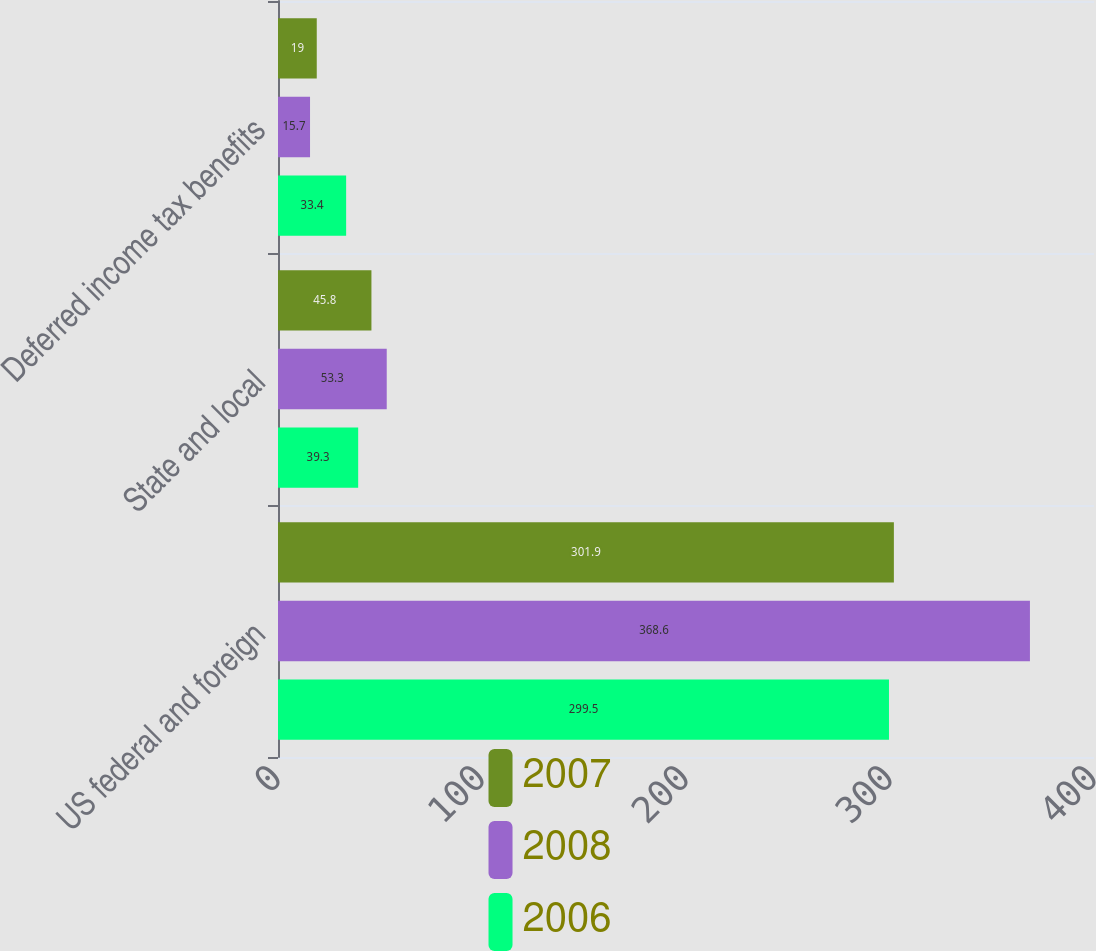<chart> <loc_0><loc_0><loc_500><loc_500><stacked_bar_chart><ecel><fcel>US federal and foreign<fcel>State and local<fcel>Deferred income tax benefits<nl><fcel>2007<fcel>301.9<fcel>45.8<fcel>19<nl><fcel>2008<fcel>368.6<fcel>53.3<fcel>15.7<nl><fcel>2006<fcel>299.5<fcel>39.3<fcel>33.4<nl></chart> 